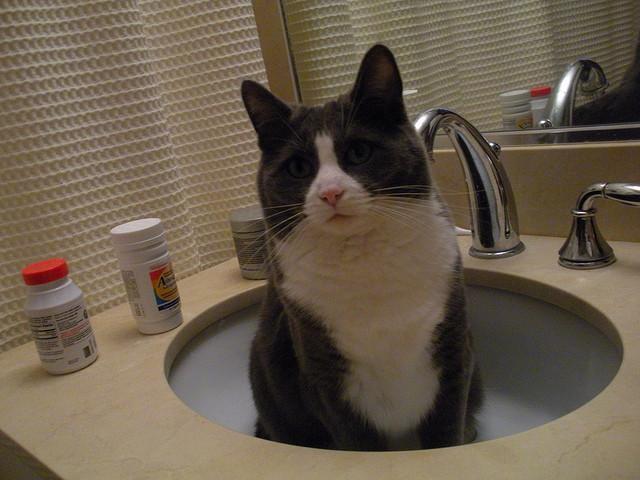How many bottles are there?
Give a very brief answer. 2. 